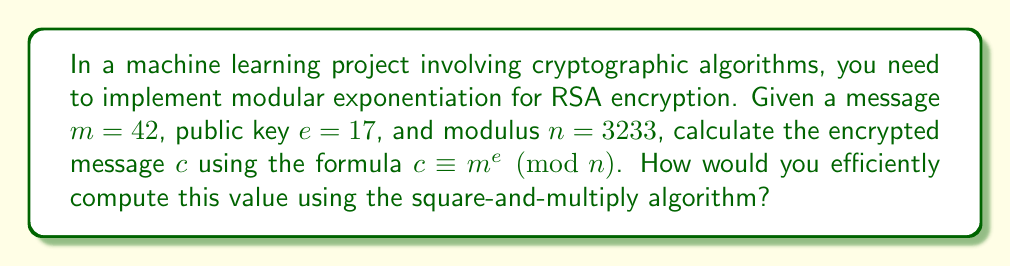What is the answer to this math problem? To efficiently compute $c \equiv m^e \pmod{n}$ using the square-and-multiply algorithm, we follow these steps:

1) Convert the exponent $e$ to binary: $17_{10} = 10001_2$

2) Initialize $c = 1$ and $x = m \bmod n = 42 \bmod 3233 = 42$

3) For each bit in $e$ from left to right:
   a) Square: $c = c^2 \bmod n$
   b) If the bit is 1, multiply: $c = (c \cdot x) \bmod n$

Step-by-step calculation:

1) $c = 1$, $x = 42$
2) First bit (1):
   $c = 1^2 \bmod 3233 = 1$
   $c = (1 \cdot 42) \bmod 3233 = 42$
3) Second bit (0):
   $c = 42^2 \bmod 3233 = 1764 \bmod 3233 = 1764$
4) Third bit (0):
   $c = 1764^2 \bmod 3233 = 3111696 \bmod 3233 = 2969$
5) Fourth bit (0):
   $c = 2969^2 \bmod 3233 = 8814961 \bmod 3233 = 2360$
6) Fifth bit (1):
   $c = 2360^2 \bmod 3233 = 5569600 \bmod 3233 = 1008$
   $c = (1008 \cdot 42) \bmod 3233 = 42336 \bmod 3233 = 2583$

Therefore, the encrypted message $c = 2583$.
Answer: $c = 2583$ 